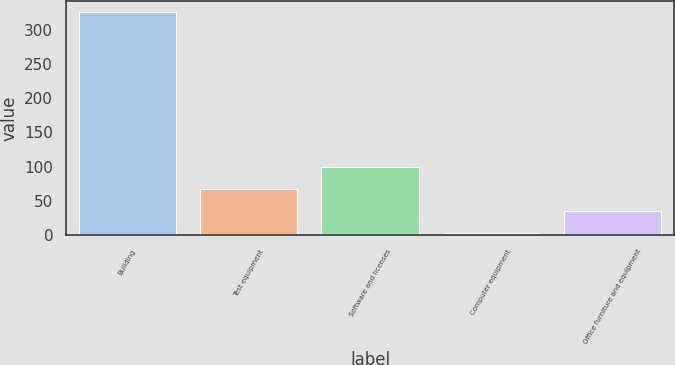Convert chart. <chart><loc_0><loc_0><loc_500><loc_500><bar_chart><fcel>Building<fcel>Test equipment<fcel>Software and licenses<fcel>Computer equipment<fcel>Office furniture and equipment<nl><fcel>325<fcel>67.4<fcel>99.6<fcel>3<fcel>35.2<nl></chart> 